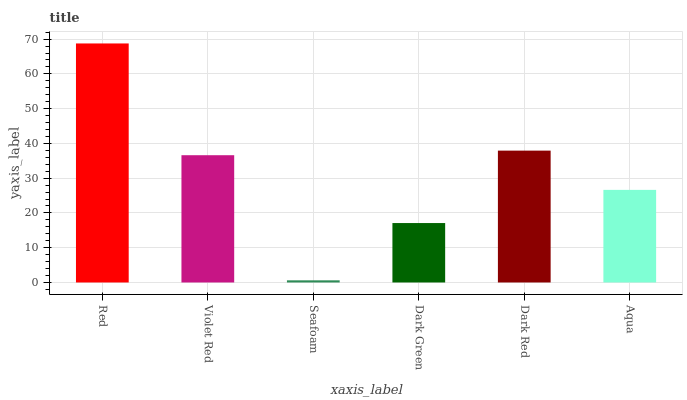Is Violet Red the minimum?
Answer yes or no. No. Is Violet Red the maximum?
Answer yes or no. No. Is Red greater than Violet Red?
Answer yes or no. Yes. Is Violet Red less than Red?
Answer yes or no. Yes. Is Violet Red greater than Red?
Answer yes or no. No. Is Red less than Violet Red?
Answer yes or no. No. Is Violet Red the high median?
Answer yes or no. Yes. Is Aqua the low median?
Answer yes or no. Yes. Is Red the high median?
Answer yes or no. No. Is Seafoam the low median?
Answer yes or no. No. 